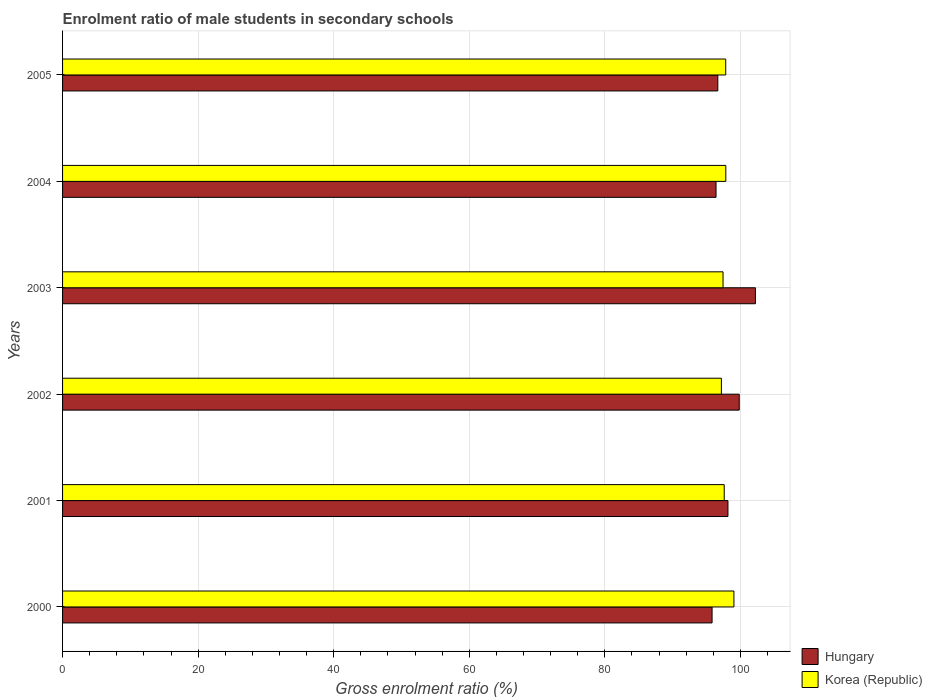How many different coloured bars are there?
Keep it short and to the point. 2. Are the number of bars on each tick of the Y-axis equal?
Provide a succinct answer. Yes. How many bars are there on the 3rd tick from the bottom?
Your response must be concise. 2. What is the label of the 2nd group of bars from the top?
Provide a succinct answer. 2004. In how many cases, is the number of bars for a given year not equal to the number of legend labels?
Provide a succinct answer. 0. What is the enrolment ratio of male students in secondary schools in Hungary in 2000?
Your response must be concise. 95.82. Across all years, what is the maximum enrolment ratio of male students in secondary schools in Korea (Republic)?
Offer a very short reply. 99.04. Across all years, what is the minimum enrolment ratio of male students in secondary schools in Hungary?
Give a very brief answer. 95.82. In which year was the enrolment ratio of male students in secondary schools in Korea (Republic) minimum?
Provide a succinct answer. 2002. What is the total enrolment ratio of male students in secondary schools in Hungary in the graph?
Your response must be concise. 589.08. What is the difference between the enrolment ratio of male students in secondary schools in Korea (Republic) in 2002 and that in 2003?
Your response must be concise. -0.24. What is the difference between the enrolment ratio of male students in secondary schools in Korea (Republic) in 2001 and the enrolment ratio of male students in secondary schools in Hungary in 2003?
Your answer should be very brief. -4.61. What is the average enrolment ratio of male students in secondary schools in Korea (Republic) per year?
Offer a terse response. 97.83. In the year 2003, what is the difference between the enrolment ratio of male students in secondary schools in Hungary and enrolment ratio of male students in secondary schools in Korea (Republic)?
Your response must be concise. 4.78. What is the ratio of the enrolment ratio of male students in secondary schools in Hungary in 2001 to that in 2002?
Provide a short and direct response. 0.98. Is the difference between the enrolment ratio of male students in secondary schools in Hungary in 2002 and 2004 greater than the difference between the enrolment ratio of male students in secondary schools in Korea (Republic) in 2002 and 2004?
Make the answer very short. Yes. What is the difference between the highest and the second highest enrolment ratio of male students in secondary schools in Hungary?
Your answer should be very brief. 2.39. What is the difference between the highest and the lowest enrolment ratio of male students in secondary schools in Hungary?
Your answer should be very brief. 6.4. Is the sum of the enrolment ratio of male students in secondary schools in Hungary in 2003 and 2004 greater than the maximum enrolment ratio of male students in secondary schools in Korea (Republic) across all years?
Your response must be concise. Yes. What does the 1st bar from the bottom in 2000 represents?
Offer a very short reply. Hungary. How many bars are there?
Offer a terse response. 12. How many years are there in the graph?
Keep it short and to the point. 6. Does the graph contain grids?
Keep it short and to the point. Yes. Where does the legend appear in the graph?
Make the answer very short. Bottom right. How many legend labels are there?
Your answer should be very brief. 2. What is the title of the graph?
Make the answer very short. Enrolment ratio of male students in secondary schools. What is the label or title of the X-axis?
Make the answer very short. Gross enrolment ratio (%). What is the label or title of the Y-axis?
Make the answer very short. Years. What is the Gross enrolment ratio (%) in Hungary in 2000?
Offer a very short reply. 95.82. What is the Gross enrolment ratio (%) of Korea (Republic) in 2000?
Keep it short and to the point. 99.04. What is the Gross enrolment ratio (%) of Hungary in 2001?
Your response must be concise. 98.16. What is the Gross enrolment ratio (%) in Korea (Republic) in 2001?
Provide a succinct answer. 97.61. What is the Gross enrolment ratio (%) in Hungary in 2002?
Make the answer very short. 99.82. What is the Gross enrolment ratio (%) of Korea (Republic) in 2002?
Make the answer very short. 97.19. What is the Gross enrolment ratio (%) in Hungary in 2003?
Keep it short and to the point. 102.22. What is the Gross enrolment ratio (%) of Korea (Republic) in 2003?
Your response must be concise. 97.44. What is the Gross enrolment ratio (%) of Hungary in 2004?
Provide a succinct answer. 96.4. What is the Gross enrolment ratio (%) of Korea (Republic) in 2004?
Keep it short and to the point. 97.84. What is the Gross enrolment ratio (%) of Hungary in 2005?
Provide a short and direct response. 96.66. What is the Gross enrolment ratio (%) of Korea (Republic) in 2005?
Offer a very short reply. 97.83. Across all years, what is the maximum Gross enrolment ratio (%) in Hungary?
Your answer should be very brief. 102.22. Across all years, what is the maximum Gross enrolment ratio (%) in Korea (Republic)?
Ensure brevity in your answer.  99.04. Across all years, what is the minimum Gross enrolment ratio (%) of Hungary?
Offer a very short reply. 95.82. Across all years, what is the minimum Gross enrolment ratio (%) in Korea (Republic)?
Your answer should be very brief. 97.19. What is the total Gross enrolment ratio (%) in Hungary in the graph?
Your answer should be very brief. 589.08. What is the total Gross enrolment ratio (%) of Korea (Republic) in the graph?
Offer a terse response. 586.95. What is the difference between the Gross enrolment ratio (%) of Hungary in 2000 and that in 2001?
Your answer should be very brief. -2.34. What is the difference between the Gross enrolment ratio (%) of Korea (Republic) in 2000 and that in 2001?
Keep it short and to the point. 1.43. What is the difference between the Gross enrolment ratio (%) of Hungary in 2000 and that in 2002?
Offer a very short reply. -4.01. What is the difference between the Gross enrolment ratio (%) of Korea (Republic) in 2000 and that in 2002?
Make the answer very short. 1.85. What is the difference between the Gross enrolment ratio (%) in Hungary in 2000 and that in 2003?
Your answer should be compact. -6.4. What is the difference between the Gross enrolment ratio (%) in Korea (Republic) in 2000 and that in 2003?
Keep it short and to the point. 1.6. What is the difference between the Gross enrolment ratio (%) in Hungary in 2000 and that in 2004?
Your response must be concise. -0.58. What is the difference between the Gross enrolment ratio (%) of Korea (Republic) in 2000 and that in 2004?
Give a very brief answer. 1.19. What is the difference between the Gross enrolment ratio (%) of Hungary in 2000 and that in 2005?
Offer a very short reply. -0.85. What is the difference between the Gross enrolment ratio (%) of Korea (Republic) in 2000 and that in 2005?
Offer a very short reply. 1.21. What is the difference between the Gross enrolment ratio (%) in Hungary in 2001 and that in 2002?
Make the answer very short. -1.66. What is the difference between the Gross enrolment ratio (%) of Korea (Republic) in 2001 and that in 2002?
Make the answer very short. 0.42. What is the difference between the Gross enrolment ratio (%) in Hungary in 2001 and that in 2003?
Provide a short and direct response. -4.06. What is the difference between the Gross enrolment ratio (%) in Korea (Republic) in 2001 and that in 2003?
Offer a terse response. 0.17. What is the difference between the Gross enrolment ratio (%) in Hungary in 2001 and that in 2004?
Your answer should be very brief. 1.76. What is the difference between the Gross enrolment ratio (%) of Korea (Republic) in 2001 and that in 2004?
Ensure brevity in your answer.  -0.23. What is the difference between the Gross enrolment ratio (%) of Hungary in 2001 and that in 2005?
Your answer should be compact. 1.5. What is the difference between the Gross enrolment ratio (%) in Korea (Republic) in 2001 and that in 2005?
Offer a very short reply. -0.22. What is the difference between the Gross enrolment ratio (%) of Hungary in 2002 and that in 2003?
Give a very brief answer. -2.39. What is the difference between the Gross enrolment ratio (%) of Korea (Republic) in 2002 and that in 2003?
Make the answer very short. -0.24. What is the difference between the Gross enrolment ratio (%) of Hungary in 2002 and that in 2004?
Your answer should be compact. 3.42. What is the difference between the Gross enrolment ratio (%) in Korea (Republic) in 2002 and that in 2004?
Give a very brief answer. -0.65. What is the difference between the Gross enrolment ratio (%) of Hungary in 2002 and that in 2005?
Give a very brief answer. 3.16. What is the difference between the Gross enrolment ratio (%) of Korea (Republic) in 2002 and that in 2005?
Offer a terse response. -0.64. What is the difference between the Gross enrolment ratio (%) in Hungary in 2003 and that in 2004?
Give a very brief answer. 5.81. What is the difference between the Gross enrolment ratio (%) in Korea (Republic) in 2003 and that in 2004?
Keep it short and to the point. -0.41. What is the difference between the Gross enrolment ratio (%) in Hungary in 2003 and that in 2005?
Give a very brief answer. 5.55. What is the difference between the Gross enrolment ratio (%) of Korea (Republic) in 2003 and that in 2005?
Keep it short and to the point. -0.4. What is the difference between the Gross enrolment ratio (%) of Hungary in 2004 and that in 2005?
Provide a succinct answer. -0.26. What is the difference between the Gross enrolment ratio (%) of Korea (Republic) in 2004 and that in 2005?
Offer a very short reply. 0.01. What is the difference between the Gross enrolment ratio (%) of Hungary in 2000 and the Gross enrolment ratio (%) of Korea (Republic) in 2001?
Offer a terse response. -1.79. What is the difference between the Gross enrolment ratio (%) of Hungary in 2000 and the Gross enrolment ratio (%) of Korea (Republic) in 2002?
Give a very brief answer. -1.37. What is the difference between the Gross enrolment ratio (%) in Hungary in 2000 and the Gross enrolment ratio (%) in Korea (Republic) in 2003?
Offer a terse response. -1.62. What is the difference between the Gross enrolment ratio (%) in Hungary in 2000 and the Gross enrolment ratio (%) in Korea (Republic) in 2004?
Your answer should be compact. -2.03. What is the difference between the Gross enrolment ratio (%) of Hungary in 2000 and the Gross enrolment ratio (%) of Korea (Republic) in 2005?
Make the answer very short. -2.01. What is the difference between the Gross enrolment ratio (%) in Hungary in 2001 and the Gross enrolment ratio (%) in Korea (Republic) in 2002?
Offer a very short reply. 0.97. What is the difference between the Gross enrolment ratio (%) of Hungary in 2001 and the Gross enrolment ratio (%) of Korea (Republic) in 2003?
Provide a short and direct response. 0.73. What is the difference between the Gross enrolment ratio (%) in Hungary in 2001 and the Gross enrolment ratio (%) in Korea (Republic) in 2004?
Your response must be concise. 0.32. What is the difference between the Gross enrolment ratio (%) of Hungary in 2001 and the Gross enrolment ratio (%) of Korea (Republic) in 2005?
Keep it short and to the point. 0.33. What is the difference between the Gross enrolment ratio (%) in Hungary in 2002 and the Gross enrolment ratio (%) in Korea (Republic) in 2003?
Provide a succinct answer. 2.39. What is the difference between the Gross enrolment ratio (%) of Hungary in 2002 and the Gross enrolment ratio (%) of Korea (Republic) in 2004?
Your response must be concise. 1.98. What is the difference between the Gross enrolment ratio (%) of Hungary in 2002 and the Gross enrolment ratio (%) of Korea (Republic) in 2005?
Your answer should be very brief. 1.99. What is the difference between the Gross enrolment ratio (%) in Hungary in 2003 and the Gross enrolment ratio (%) in Korea (Republic) in 2004?
Your response must be concise. 4.37. What is the difference between the Gross enrolment ratio (%) in Hungary in 2003 and the Gross enrolment ratio (%) in Korea (Republic) in 2005?
Your answer should be very brief. 4.38. What is the difference between the Gross enrolment ratio (%) in Hungary in 2004 and the Gross enrolment ratio (%) in Korea (Republic) in 2005?
Ensure brevity in your answer.  -1.43. What is the average Gross enrolment ratio (%) of Hungary per year?
Make the answer very short. 98.18. What is the average Gross enrolment ratio (%) in Korea (Republic) per year?
Your answer should be compact. 97.83. In the year 2000, what is the difference between the Gross enrolment ratio (%) of Hungary and Gross enrolment ratio (%) of Korea (Republic)?
Your response must be concise. -3.22. In the year 2001, what is the difference between the Gross enrolment ratio (%) of Hungary and Gross enrolment ratio (%) of Korea (Republic)?
Provide a succinct answer. 0.55. In the year 2002, what is the difference between the Gross enrolment ratio (%) of Hungary and Gross enrolment ratio (%) of Korea (Republic)?
Your answer should be compact. 2.63. In the year 2003, what is the difference between the Gross enrolment ratio (%) of Hungary and Gross enrolment ratio (%) of Korea (Republic)?
Your response must be concise. 4.78. In the year 2004, what is the difference between the Gross enrolment ratio (%) in Hungary and Gross enrolment ratio (%) in Korea (Republic)?
Give a very brief answer. -1.44. In the year 2005, what is the difference between the Gross enrolment ratio (%) of Hungary and Gross enrolment ratio (%) of Korea (Republic)?
Your answer should be very brief. -1.17. What is the ratio of the Gross enrolment ratio (%) in Hungary in 2000 to that in 2001?
Provide a succinct answer. 0.98. What is the ratio of the Gross enrolment ratio (%) of Korea (Republic) in 2000 to that in 2001?
Your response must be concise. 1.01. What is the ratio of the Gross enrolment ratio (%) of Hungary in 2000 to that in 2002?
Offer a very short reply. 0.96. What is the ratio of the Gross enrolment ratio (%) of Hungary in 2000 to that in 2003?
Your response must be concise. 0.94. What is the ratio of the Gross enrolment ratio (%) in Korea (Republic) in 2000 to that in 2003?
Offer a very short reply. 1.02. What is the ratio of the Gross enrolment ratio (%) in Korea (Republic) in 2000 to that in 2004?
Your response must be concise. 1.01. What is the ratio of the Gross enrolment ratio (%) in Korea (Republic) in 2000 to that in 2005?
Offer a terse response. 1.01. What is the ratio of the Gross enrolment ratio (%) of Hungary in 2001 to that in 2002?
Your response must be concise. 0.98. What is the ratio of the Gross enrolment ratio (%) of Korea (Republic) in 2001 to that in 2002?
Offer a terse response. 1. What is the ratio of the Gross enrolment ratio (%) in Hungary in 2001 to that in 2003?
Offer a terse response. 0.96. What is the ratio of the Gross enrolment ratio (%) in Hungary in 2001 to that in 2004?
Offer a terse response. 1.02. What is the ratio of the Gross enrolment ratio (%) of Korea (Republic) in 2001 to that in 2004?
Your response must be concise. 1. What is the ratio of the Gross enrolment ratio (%) of Hungary in 2001 to that in 2005?
Offer a very short reply. 1.02. What is the ratio of the Gross enrolment ratio (%) in Korea (Republic) in 2001 to that in 2005?
Keep it short and to the point. 1. What is the ratio of the Gross enrolment ratio (%) of Hungary in 2002 to that in 2003?
Your answer should be compact. 0.98. What is the ratio of the Gross enrolment ratio (%) of Hungary in 2002 to that in 2004?
Make the answer very short. 1.04. What is the ratio of the Gross enrolment ratio (%) in Hungary in 2002 to that in 2005?
Your response must be concise. 1.03. What is the ratio of the Gross enrolment ratio (%) of Korea (Republic) in 2002 to that in 2005?
Keep it short and to the point. 0.99. What is the ratio of the Gross enrolment ratio (%) of Hungary in 2003 to that in 2004?
Keep it short and to the point. 1.06. What is the ratio of the Gross enrolment ratio (%) in Hungary in 2003 to that in 2005?
Make the answer very short. 1.06. What is the ratio of the Gross enrolment ratio (%) in Korea (Republic) in 2003 to that in 2005?
Provide a short and direct response. 1. What is the difference between the highest and the second highest Gross enrolment ratio (%) in Hungary?
Your response must be concise. 2.39. What is the difference between the highest and the second highest Gross enrolment ratio (%) in Korea (Republic)?
Give a very brief answer. 1.19. What is the difference between the highest and the lowest Gross enrolment ratio (%) of Hungary?
Provide a short and direct response. 6.4. What is the difference between the highest and the lowest Gross enrolment ratio (%) of Korea (Republic)?
Your answer should be compact. 1.85. 